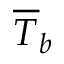Convert formula to latex. <formula><loc_0><loc_0><loc_500><loc_500>\overline { T } _ { b }</formula> 